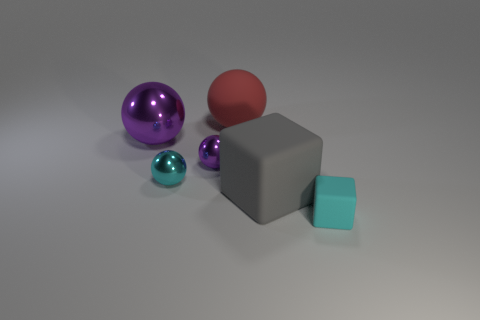Add 1 gray matte objects. How many objects exist? 7 Subtract all spheres. How many objects are left? 2 Add 6 matte blocks. How many matte blocks are left? 8 Add 4 big gray cubes. How many big gray cubes exist? 5 Subtract 0 brown cylinders. How many objects are left? 6 Subtract all tiny cyan cubes. Subtract all tiny cyan matte cubes. How many objects are left? 4 